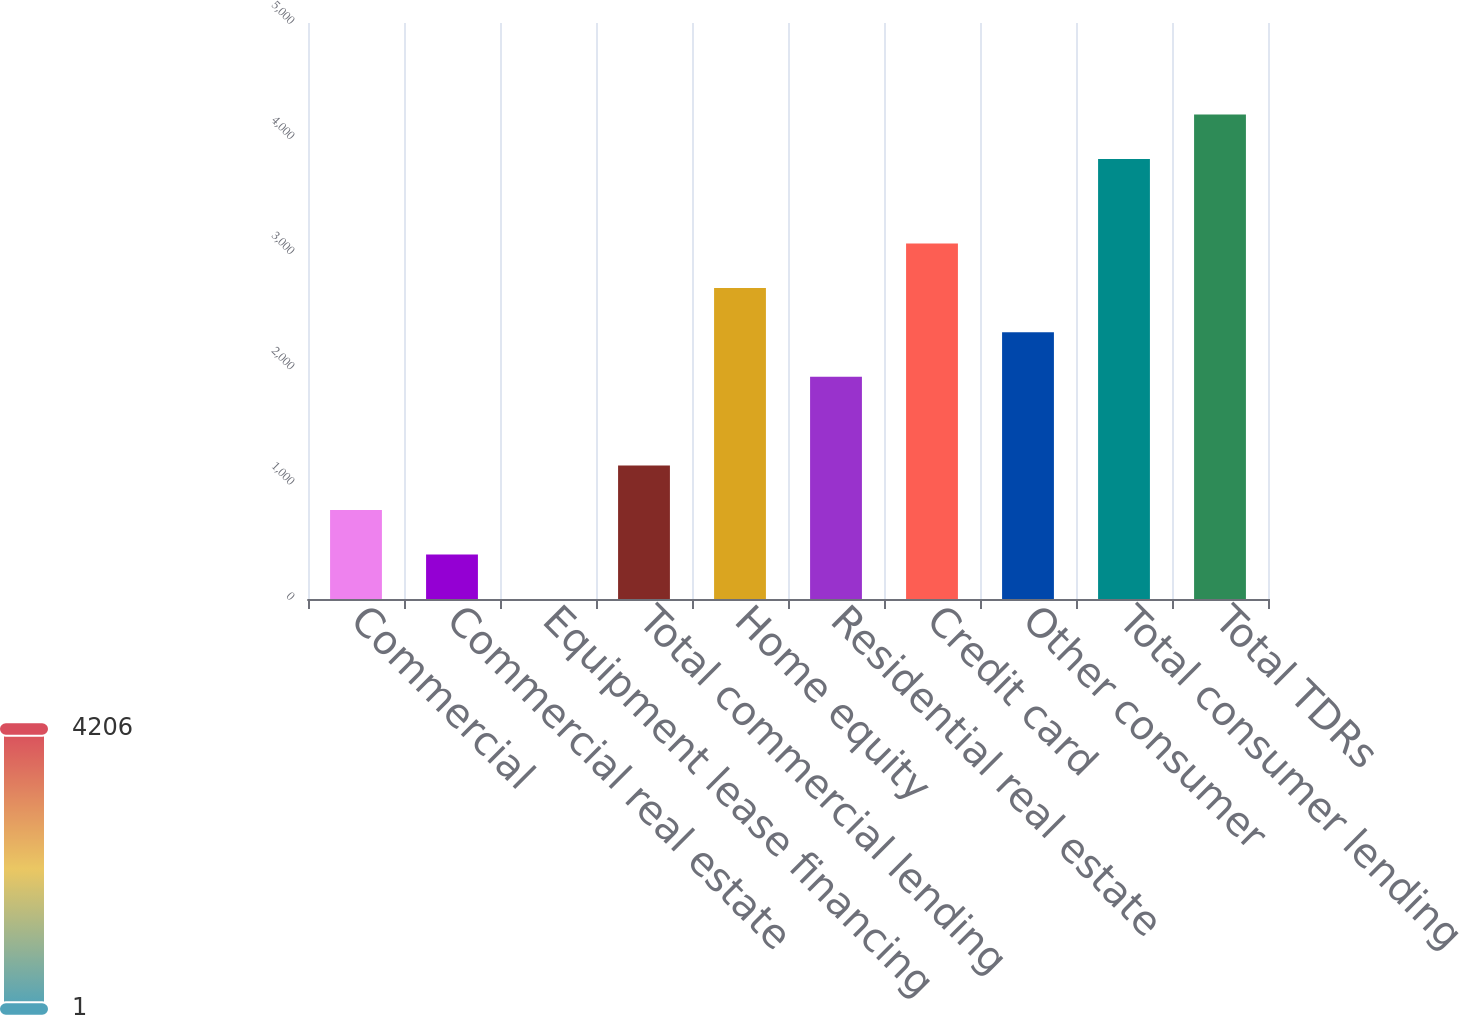Convert chart to OTSL. <chart><loc_0><loc_0><loc_500><loc_500><bar_chart><fcel>Commercial<fcel>Commercial real estate<fcel>Equipment lease financing<fcel>Total commercial lending<fcel>Home equity<fcel>Residential real estate<fcel>Credit card<fcel>Other consumer<fcel>Total consumer lending<fcel>Total TDRs<nl><fcel>772.2<fcel>386.6<fcel>1<fcel>1157.8<fcel>2700.2<fcel>1929<fcel>3085.8<fcel>2314.6<fcel>3820<fcel>4205.6<nl></chart> 